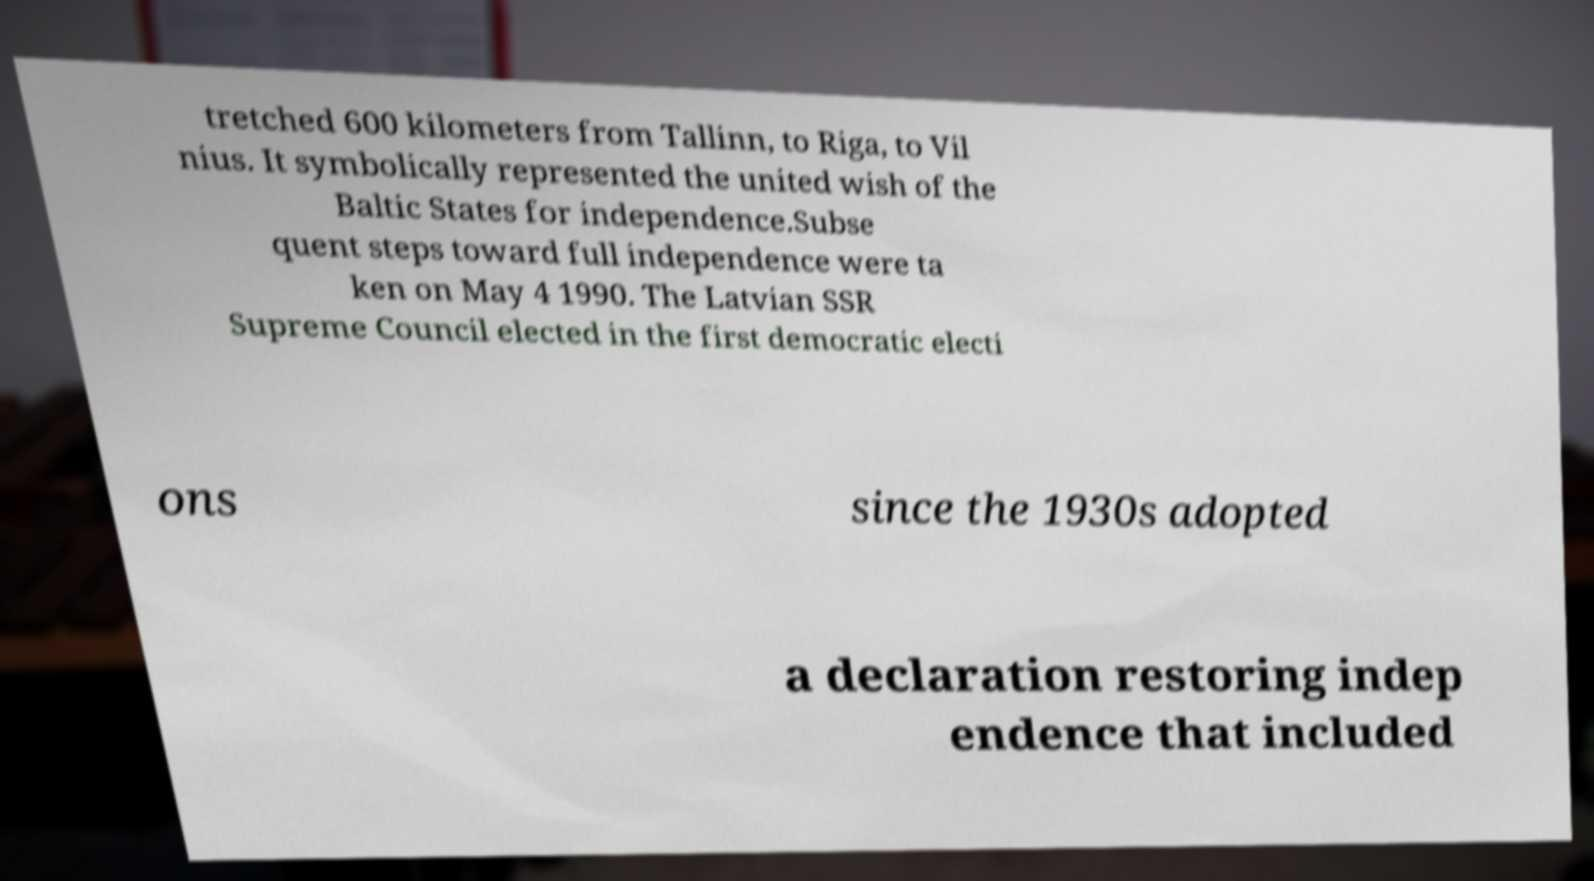Can you read and provide the text displayed in the image?This photo seems to have some interesting text. Can you extract and type it out for me? tretched 600 kilometers from Tallinn, to Riga, to Vil nius. It symbolically represented the united wish of the Baltic States for independence.Subse quent steps toward full independence were ta ken on May 4 1990. The Latvian SSR Supreme Council elected in the first democratic electi ons since the 1930s adopted a declaration restoring indep endence that included 